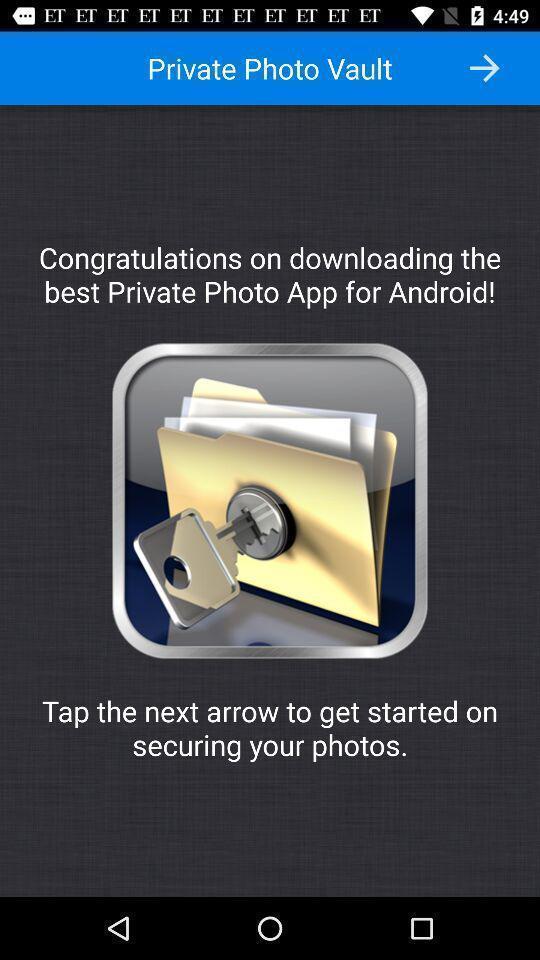Describe this image in words. Welcome page. 